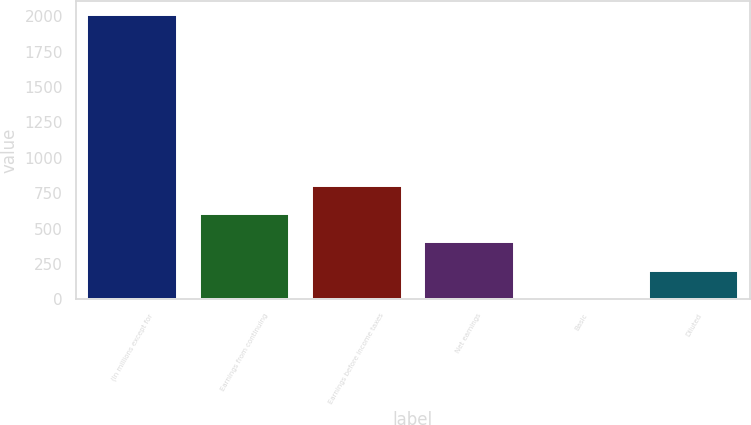Convert chart. <chart><loc_0><loc_0><loc_500><loc_500><bar_chart><fcel>(In millions except for<fcel>Earnings from continuing<fcel>Earnings before income taxes<fcel>Net earnings<fcel>Basic<fcel>Diluted<nl><fcel>2009<fcel>602.73<fcel>803.62<fcel>401.84<fcel>0.06<fcel>200.95<nl></chart> 